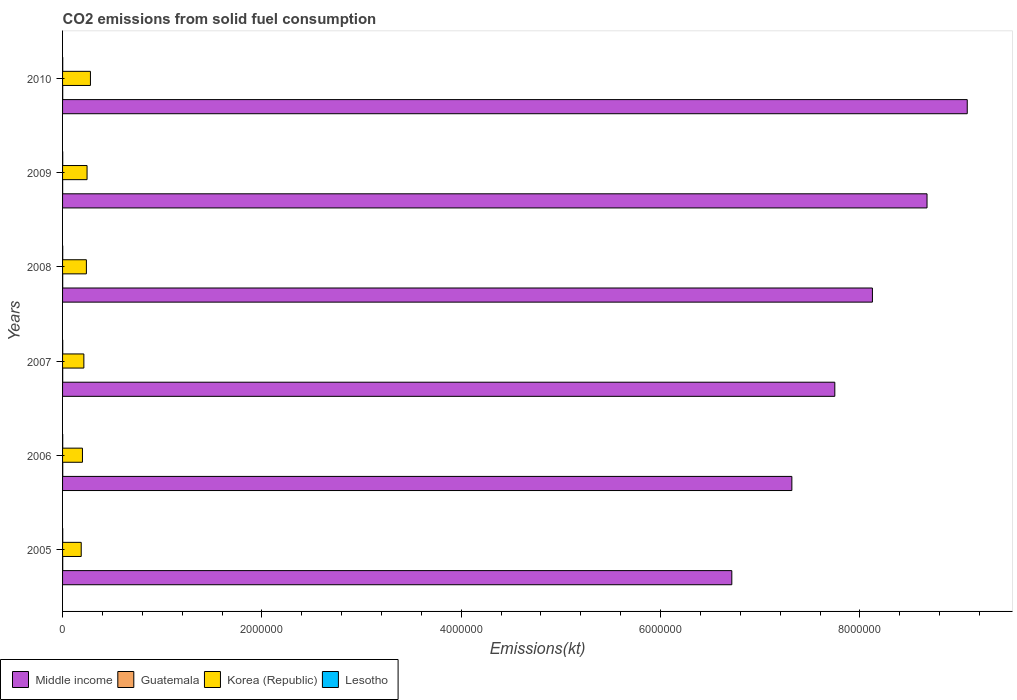How many different coloured bars are there?
Ensure brevity in your answer.  4. Are the number of bars per tick equal to the number of legend labels?
Your response must be concise. Yes. What is the label of the 1st group of bars from the top?
Your answer should be very brief. 2010. In how many cases, is the number of bars for a given year not equal to the number of legend labels?
Provide a short and direct response. 0. What is the amount of CO2 emitted in Middle income in 2008?
Your answer should be very brief. 8.13e+06. Across all years, what is the maximum amount of CO2 emitted in Lesotho?
Provide a short and direct response. 1543.81. Across all years, what is the minimum amount of CO2 emitted in Middle income?
Ensure brevity in your answer.  6.71e+06. In which year was the amount of CO2 emitted in Korea (Republic) maximum?
Give a very brief answer. 2010. In which year was the amount of CO2 emitted in Korea (Republic) minimum?
Your answer should be compact. 2005. What is the total amount of CO2 emitted in Guatemala in the graph?
Make the answer very short. 7726.37. What is the difference between the amount of CO2 emitted in Lesotho in 2005 and that in 2010?
Make the answer very short. -124.68. What is the difference between the amount of CO2 emitted in Korea (Republic) in 2010 and the amount of CO2 emitted in Guatemala in 2007?
Provide a short and direct response. 2.78e+05. What is the average amount of CO2 emitted in Guatemala per year?
Your answer should be compact. 1287.73. In the year 2006, what is the difference between the amount of CO2 emitted in Lesotho and amount of CO2 emitted in Korea (Republic)?
Make the answer very short. -1.98e+05. In how many years, is the amount of CO2 emitted in Middle income greater than 4800000 kt?
Provide a succinct answer. 6. What is the ratio of the amount of CO2 emitted in Middle income in 2006 to that in 2007?
Your response must be concise. 0.94. What is the difference between the highest and the second highest amount of CO2 emitted in Lesotho?
Your response must be concise. 25.67. What is the difference between the highest and the lowest amount of CO2 emitted in Guatemala?
Your answer should be compact. 909.42. Is it the case that in every year, the sum of the amount of CO2 emitted in Middle income and amount of CO2 emitted in Korea (Republic) is greater than the sum of amount of CO2 emitted in Lesotho and amount of CO2 emitted in Guatemala?
Your response must be concise. Yes. What does the 1st bar from the top in 2008 represents?
Your response must be concise. Lesotho. How many bars are there?
Make the answer very short. 24. Are the values on the major ticks of X-axis written in scientific E-notation?
Offer a terse response. No. Does the graph contain grids?
Provide a short and direct response. No. How are the legend labels stacked?
Ensure brevity in your answer.  Horizontal. What is the title of the graph?
Provide a succinct answer. CO2 emissions from solid fuel consumption. What is the label or title of the X-axis?
Your answer should be very brief. Emissions(kt). What is the label or title of the Y-axis?
Make the answer very short. Years. What is the Emissions(kt) in Middle income in 2005?
Provide a succinct answer. 6.71e+06. What is the Emissions(kt) in Guatemala in 2005?
Keep it short and to the point. 1562.14. What is the Emissions(kt) in Korea (Republic) in 2005?
Provide a short and direct response. 1.87e+05. What is the Emissions(kt) in Lesotho in 2005?
Keep it short and to the point. 1419.13. What is the Emissions(kt) in Middle income in 2006?
Provide a succinct answer. 7.32e+06. What is the Emissions(kt) of Guatemala in 2006?
Your answer should be compact. 1690.49. What is the Emissions(kt) in Korea (Republic) in 2006?
Keep it short and to the point. 2.00e+05. What is the Emissions(kt) of Lesotho in 2006?
Offer a very short reply. 1444.8. What is the Emissions(kt) in Middle income in 2007?
Make the answer very short. 7.75e+06. What is the Emissions(kt) of Guatemala in 2007?
Provide a succinct answer. 1188.11. What is the Emissions(kt) in Korea (Republic) in 2007?
Make the answer very short. 2.14e+05. What is the Emissions(kt) of Lesotho in 2007?
Provide a succinct answer. 1466.8. What is the Emissions(kt) of Middle income in 2008?
Your response must be concise. 8.13e+06. What is the Emissions(kt) of Guatemala in 2008?
Offer a very short reply. 1199.11. What is the Emissions(kt) of Korea (Republic) in 2008?
Provide a succinct answer. 2.39e+05. What is the Emissions(kt) in Lesotho in 2008?
Your answer should be very brief. 1496.14. What is the Emissions(kt) in Middle income in 2009?
Keep it short and to the point. 8.67e+06. What is the Emissions(kt) of Guatemala in 2009?
Give a very brief answer. 781.07. What is the Emissions(kt) of Korea (Republic) in 2009?
Provide a short and direct response. 2.46e+05. What is the Emissions(kt) in Lesotho in 2009?
Ensure brevity in your answer.  1518.14. What is the Emissions(kt) of Middle income in 2010?
Your response must be concise. 9.08e+06. What is the Emissions(kt) in Guatemala in 2010?
Keep it short and to the point. 1305.45. What is the Emissions(kt) in Korea (Republic) in 2010?
Your answer should be compact. 2.80e+05. What is the Emissions(kt) of Lesotho in 2010?
Offer a very short reply. 1543.81. Across all years, what is the maximum Emissions(kt) in Middle income?
Provide a succinct answer. 9.08e+06. Across all years, what is the maximum Emissions(kt) in Guatemala?
Offer a terse response. 1690.49. Across all years, what is the maximum Emissions(kt) in Korea (Republic)?
Your answer should be very brief. 2.80e+05. Across all years, what is the maximum Emissions(kt) of Lesotho?
Keep it short and to the point. 1543.81. Across all years, what is the minimum Emissions(kt) of Middle income?
Ensure brevity in your answer.  6.71e+06. Across all years, what is the minimum Emissions(kt) of Guatemala?
Offer a terse response. 781.07. Across all years, what is the minimum Emissions(kt) in Korea (Republic)?
Your answer should be compact. 1.87e+05. Across all years, what is the minimum Emissions(kt) in Lesotho?
Make the answer very short. 1419.13. What is the total Emissions(kt) in Middle income in the graph?
Offer a terse response. 4.77e+07. What is the total Emissions(kt) in Guatemala in the graph?
Ensure brevity in your answer.  7726.37. What is the total Emissions(kt) of Korea (Republic) in the graph?
Offer a terse response. 1.36e+06. What is the total Emissions(kt) of Lesotho in the graph?
Your answer should be compact. 8888.81. What is the difference between the Emissions(kt) of Middle income in 2005 and that in 2006?
Provide a succinct answer. -6.02e+05. What is the difference between the Emissions(kt) in Guatemala in 2005 and that in 2006?
Give a very brief answer. -128.34. What is the difference between the Emissions(kt) in Korea (Republic) in 2005 and that in 2006?
Keep it short and to the point. -1.24e+04. What is the difference between the Emissions(kt) of Lesotho in 2005 and that in 2006?
Offer a terse response. -25.67. What is the difference between the Emissions(kt) of Middle income in 2005 and that in 2007?
Give a very brief answer. -1.03e+06. What is the difference between the Emissions(kt) in Guatemala in 2005 and that in 2007?
Make the answer very short. 374.03. What is the difference between the Emissions(kt) in Korea (Republic) in 2005 and that in 2007?
Your response must be concise. -2.65e+04. What is the difference between the Emissions(kt) of Lesotho in 2005 and that in 2007?
Provide a short and direct response. -47.67. What is the difference between the Emissions(kt) in Middle income in 2005 and that in 2008?
Your answer should be compact. -1.41e+06. What is the difference between the Emissions(kt) in Guatemala in 2005 and that in 2008?
Ensure brevity in your answer.  363.03. What is the difference between the Emissions(kt) of Korea (Republic) in 2005 and that in 2008?
Your answer should be compact. -5.19e+04. What is the difference between the Emissions(kt) in Lesotho in 2005 and that in 2008?
Make the answer very short. -77.01. What is the difference between the Emissions(kt) in Middle income in 2005 and that in 2009?
Ensure brevity in your answer.  -1.96e+06. What is the difference between the Emissions(kt) of Guatemala in 2005 and that in 2009?
Offer a terse response. 781.07. What is the difference between the Emissions(kt) of Korea (Republic) in 2005 and that in 2009?
Your answer should be very brief. -5.86e+04. What is the difference between the Emissions(kt) in Lesotho in 2005 and that in 2009?
Offer a very short reply. -99.01. What is the difference between the Emissions(kt) in Middle income in 2005 and that in 2010?
Make the answer very short. -2.36e+06. What is the difference between the Emissions(kt) in Guatemala in 2005 and that in 2010?
Keep it short and to the point. 256.69. What is the difference between the Emissions(kt) in Korea (Republic) in 2005 and that in 2010?
Give a very brief answer. -9.25e+04. What is the difference between the Emissions(kt) in Lesotho in 2005 and that in 2010?
Give a very brief answer. -124.68. What is the difference between the Emissions(kt) in Middle income in 2006 and that in 2007?
Ensure brevity in your answer.  -4.31e+05. What is the difference between the Emissions(kt) of Guatemala in 2006 and that in 2007?
Your answer should be very brief. 502.38. What is the difference between the Emissions(kt) of Korea (Republic) in 2006 and that in 2007?
Make the answer very short. -1.40e+04. What is the difference between the Emissions(kt) in Lesotho in 2006 and that in 2007?
Ensure brevity in your answer.  -22. What is the difference between the Emissions(kt) of Middle income in 2006 and that in 2008?
Provide a short and direct response. -8.08e+05. What is the difference between the Emissions(kt) in Guatemala in 2006 and that in 2008?
Keep it short and to the point. 491.38. What is the difference between the Emissions(kt) of Korea (Republic) in 2006 and that in 2008?
Your answer should be very brief. -3.95e+04. What is the difference between the Emissions(kt) in Lesotho in 2006 and that in 2008?
Provide a succinct answer. -51.34. What is the difference between the Emissions(kt) of Middle income in 2006 and that in 2009?
Keep it short and to the point. -1.36e+06. What is the difference between the Emissions(kt) of Guatemala in 2006 and that in 2009?
Offer a very short reply. 909.42. What is the difference between the Emissions(kt) of Korea (Republic) in 2006 and that in 2009?
Ensure brevity in your answer.  -4.62e+04. What is the difference between the Emissions(kt) of Lesotho in 2006 and that in 2009?
Your answer should be compact. -73.34. What is the difference between the Emissions(kt) in Middle income in 2006 and that in 2010?
Offer a very short reply. -1.76e+06. What is the difference between the Emissions(kt) in Guatemala in 2006 and that in 2010?
Provide a short and direct response. 385.04. What is the difference between the Emissions(kt) in Korea (Republic) in 2006 and that in 2010?
Your response must be concise. -8.01e+04. What is the difference between the Emissions(kt) of Lesotho in 2006 and that in 2010?
Keep it short and to the point. -99.01. What is the difference between the Emissions(kt) of Middle income in 2007 and that in 2008?
Your answer should be very brief. -3.77e+05. What is the difference between the Emissions(kt) in Guatemala in 2007 and that in 2008?
Provide a short and direct response. -11. What is the difference between the Emissions(kt) of Korea (Republic) in 2007 and that in 2008?
Provide a short and direct response. -2.55e+04. What is the difference between the Emissions(kt) in Lesotho in 2007 and that in 2008?
Give a very brief answer. -29.34. What is the difference between the Emissions(kt) in Middle income in 2007 and that in 2009?
Your answer should be very brief. -9.25e+05. What is the difference between the Emissions(kt) in Guatemala in 2007 and that in 2009?
Give a very brief answer. 407.04. What is the difference between the Emissions(kt) in Korea (Republic) in 2007 and that in 2009?
Offer a very short reply. -3.22e+04. What is the difference between the Emissions(kt) of Lesotho in 2007 and that in 2009?
Keep it short and to the point. -51.34. What is the difference between the Emissions(kt) in Middle income in 2007 and that in 2010?
Your response must be concise. -1.33e+06. What is the difference between the Emissions(kt) of Guatemala in 2007 and that in 2010?
Your answer should be compact. -117.34. What is the difference between the Emissions(kt) in Korea (Republic) in 2007 and that in 2010?
Provide a succinct answer. -6.61e+04. What is the difference between the Emissions(kt) in Lesotho in 2007 and that in 2010?
Ensure brevity in your answer.  -77.01. What is the difference between the Emissions(kt) of Middle income in 2008 and that in 2009?
Keep it short and to the point. -5.48e+05. What is the difference between the Emissions(kt) of Guatemala in 2008 and that in 2009?
Your answer should be compact. 418.04. What is the difference between the Emissions(kt) in Korea (Republic) in 2008 and that in 2009?
Your answer should be very brief. -6703.28. What is the difference between the Emissions(kt) of Lesotho in 2008 and that in 2009?
Make the answer very short. -22. What is the difference between the Emissions(kt) in Middle income in 2008 and that in 2010?
Your answer should be compact. -9.51e+05. What is the difference between the Emissions(kt) in Guatemala in 2008 and that in 2010?
Provide a short and direct response. -106.34. What is the difference between the Emissions(kt) in Korea (Republic) in 2008 and that in 2010?
Your answer should be compact. -4.06e+04. What is the difference between the Emissions(kt) in Lesotho in 2008 and that in 2010?
Your answer should be very brief. -47.67. What is the difference between the Emissions(kt) in Middle income in 2009 and that in 2010?
Offer a very short reply. -4.04e+05. What is the difference between the Emissions(kt) of Guatemala in 2009 and that in 2010?
Offer a very short reply. -524.38. What is the difference between the Emissions(kt) in Korea (Republic) in 2009 and that in 2010?
Provide a succinct answer. -3.39e+04. What is the difference between the Emissions(kt) of Lesotho in 2009 and that in 2010?
Provide a short and direct response. -25.67. What is the difference between the Emissions(kt) of Middle income in 2005 and the Emissions(kt) of Guatemala in 2006?
Offer a very short reply. 6.71e+06. What is the difference between the Emissions(kt) in Middle income in 2005 and the Emissions(kt) in Korea (Republic) in 2006?
Offer a terse response. 6.52e+06. What is the difference between the Emissions(kt) in Middle income in 2005 and the Emissions(kt) in Lesotho in 2006?
Your answer should be very brief. 6.71e+06. What is the difference between the Emissions(kt) of Guatemala in 2005 and the Emissions(kt) of Korea (Republic) in 2006?
Keep it short and to the point. -1.98e+05. What is the difference between the Emissions(kt) in Guatemala in 2005 and the Emissions(kt) in Lesotho in 2006?
Your answer should be compact. 117.34. What is the difference between the Emissions(kt) of Korea (Republic) in 2005 and the Emissions(kt) of Lesotho in 2006?
Give a very brief answer. 1.86e+05. What is the difference between the Emissions(kt) of Middle income in 2005 and the Emissions(kt) of Guatemala in 2007?
Your answer should be very brief. 6.71e+06. What is the difference between the Emissions(kt) of Middle income in 2005 and the Emissions(kt) of Korea (Republic) in 2007?
Provide a succinct answer. 6.50e+06. What is the difference between the Emissions(kt) of Middle income in 2005 and the Emissions(kt) of Lesotho in 2007?
Keep it short and to the point. 6.71e+06. What is the difference between the Emissions(kt) in Guatemala in 2005 and the Emissions(kt) in Korea (Republic) in 2007?
Ensure brevity in your answer.  -2.12e+05. What is the difference between the Emissions(kt) of Guatemala in 2005 and the Emissions(kt) of Lesotho in 2007?
Your answer should be compact. 95.34. What is the difference between the Emissions(kt) in Korea (Republic) in 2005 and the Emissions(kt) in Lesotho in 2007?
Offer a very short reply. 1.86e+05. What is the difference between the Emissions(kt) of Middle income in 2005 and the Emissions(kt) of Guatemala in 2008?
Keep it short and to the point. 6.71e+06. What is the difference between the Emissions(kt) in Middle income in 2005 and the Emissions(kt) in Korea (Republic) in 2008?
Your response must be concise. 6.48e+06. What is the difference between the Emissions(kt) in Middle income in 2005 and the Emissions(kt) in Lesotho in 2008?
Make the answer very short. 6.71e+06. What is the difference between the Emissions(kt) in Guatemala in 2005 and the Emissions(kt) in Korea (Republic) in 2008?
Offer a terse response. -2.37e+05. What is the difference between the Emissions(kt) in Guatemala in 2005 and the Emissions(kt) in Lesotho in 2008?
Give a very brief answer. 66.01. What is the difference between the Emissions(kt) of Korea (Republic) in 2005 and the Emissions(kt) of Lesotho in 2008?
Your response must be concise. 1.86e+05. What is the difference between the Emissions(kt) of Middle income in 2005 and the Emissions(kt) of Guatemala in 2009?
Your answer should be very brief. 6.71e+06. What is the difference between the Emissions(kt) of Middle income in 2005 and the Emissions(kt) of Korea (Republic) in 2009?
Offer a terse response. 6.47e+06. What is the difference between the Emissions(kt) of Middle income in 2005 and the Emissions(kt) of Lesotho in 2009?
Give a very brief answer. 6.71e+06. What is the difference between the Emissions(kt) of Guatemala in 2005 and the Emissions(kt) of Korea (Republic) in 2009?
Offer a very short reply. -2.44e+05. What is the difference between the Emissions(kt) of Guatemala in 2005 and the Emissions(kt) of Lesotho in 2009?
Offer a very short reply. 44. What is the difference between the Emissions(kt) of Korea (Republic) in 2005 and the Emissions(kt) of Lesotho in 2009?
Offer a terse response. 1.86e+05. What is the difference between the Emissions(kt) in Middle income in 2005 and the Emissions(kt) in Guatemala in 2010?
Keep it short and to the point. 6.71e+06. What is the difference between the Emissions(kt) in Middle income in 2005 and the Emissions(kt) in Korea (Republic) in 2010?
Your response must be concise. 6.44e+06. What is the difference between the Emissions(kt) in Middle income in 2005 and the Emissions(kt) in Lesotho in 2010?
Provide a succinct answer. 6.71e+06. What is the difference between the Emissions(kt) in Guatemala in 2005 and the Emissions(kt) in Korea (Republic) in 2010?
Give a very brief answer. -2.78e+05. What is the difference between the Emissions(kt) of Guatemala in 2005 and the Emissions(kt) of Lesotho in 2010?
Keep it short and to the point. 18.34. What is the difference between the Emissions(kt) of Korea (Republic) in 2005 and the Emissions(kt) of Lesotho in 2010?
Your answer should be very brief. 1.86e+05. What is the difference between the Emissions(kt) of Middle income in 2006 and the Emissions(kt) of Guatemala in 2007?
Your answer should be very brief. 7.32e+06. What is the difference between the Emissions(kt) of Middle income in 2006 and the Emissions(kt) of Korea (Republic) in 2007?
Offer a very short reply. 7.10e+06. What is the difference between the Emissions(kt) in Middle income in 2006 and the Emissions(kt) in Lesotho in 2007?
Make the answer very short. 7.32e+06. What is the difference between the Emissions(kt) in Guatemala in 2006 and the Emissions(kt) in Korea (Republic) in 2007?
Give a very brief answer. -2.12e+05. What is the difference between the Emissions(kt) of Guatemala in 2006 and the Emissions(kt) of Lesotho in 2007?
Provide a short and direct response. 223.69. What is the difference between the Emissions(kt) in Korea (Republic) in 2006 and the Emissions(kt) in Lesotho in 2007?
Offer a very short reply. 1.98e+05. What is the difference between the Emissions(kt) of Middle income in 2006 and the Emissions(kt) of Guatemala in 2008?
Provide a succinct answer. 7.32e+06. What is the difference between the Emissions(kt) in Middle income in 2006 and the Emissions(kt) in Korea (Republic) in 2008?
Give a very brief answer. 7.08e+06. What is the difference between the Emissions(kt) in Middle income in 2006 and the Emissions(kt) in Lesotho in 2008?
Give a very brief answer. 7.32e+06. What is the difference between the Emissions(kt) in Guatemala in 2006 and the Emissions(kt) in Korea (Republic) in 2008?
Offer a very short reply. -2.37e+05. What is the difference between the Emissions(kt) of Guatemala in 2006 and the Emissions(kt) of Lesotho in 2008?
Keep it short and to the point. 194.35. What is the difference between the Emissions(kt) of Korea (Republic) in 2006 and the Emissions(kt) of Lesotho in 2008?
Give a very brief answer. 1.98e+05. What is the difference between the Emissions(kt) of Middle income in 2006 and the Emissions(kt) of Guatemala in 2009?
Keep it short and to the point. 7.32e+06. What is the difference between the Emissions(kt) in Middle income in 2006 and the Emissions(kt) in Korea (Republic) in 2009?
Offer a very short reply. 7.07e+06. What is the difference between the Emissions(kt) in Middle income in 2006 and the Emissions(kt) in Lesotho in 2009?
Provide a short and direct response. 7.32e+06. What is the difference between the Emissions(kt) of Guatemala in 2006 and the Emissions(kt) of Korea (Republic) in 2009?
Provide a succinct answer. -2.44e+05. What is the difference between the Emissions(kt) of Guatemala in 2006 and the Emissions(kt) of Lesotho in 2009?
Provide a succinct answer. 172.35. What is the difference between the Emissions(kt) of Korea (Republic) in 2006 and the Emissions(kt) of Lesotho in 2009?
Offer a terse response. 1.98e+05. What is the difference between the Emissions(kt) in Middle income in 2006 and the Emissions(kt) in Guatemala in 2010?
Offer a very short reply. 7.32e+06. What is the difference between the Emissions(kt) in Middle income in 2006 and the Emissions(kt) in Korea (Republic) in 2010?
Provide a succinct answer. 7.04e+06. What is the difference between the Emissions(kt) of Middle income in 2006 and the Emissions(kt) of Lesotho in 2010?
Offer a very short reply. 7.32e+06. What is the difference between the Emissions(kt) in Guatemala in 2006 and the Emissions(kt) in Korea (Republic) in 2010?
Your response must be concise. -2.78e+05. What is the difference between the Emissions(kt) of Guatemala in 2006 and the Emissions(kt) of Lesotho in 2010?
Give a very brief answer. 146.68. What is the difference between the Emissions(kt) in Korea (Republic) in 2006 and the Emissions(kt) in Lesotho in 2010?
Ensure brevity in your answer.  1.98e+05. What is the difference between the Emissions(kt) in Middle income in 2007 and the Emissions(kt) in Guatemala in 2008?
Provide a succinct answer. 7.75e+06. What is the difference between the Emissions(kt) in Middle income in 2007 and the Emissions(kt) in Korea (Republic) in 2008?
Your answer should be compact. 7.51e+06. What is the difference between the Emissions(kt) of Middle income in 2007 and the Emissions(kt) of Lesotho in 2008?
Offer a terse response. 7.75e+06. What is the difference between the Emissions(kt) of Guatemala in 2007 and the Emissions(kt) of Korea (Republic) in 2008?
Give a very brief answer. -2.38e+05. What is the difference between the Emissions(kt) of Guatemala in 2007 and the Emissions(kt) of Lesotho in 2008?
Offer a very short reply. -308.03. What is the difference between the Emissions(kt) of Korea (Republic) in 2007 and the Emissions(kt) of Lesotho in 2008?
Offer a terse response. 2.12e+05. What is the difference between the Emissions(kt) of Middle income in 2007 and the Emissions(kt) of Guatemala in 2009?
Your answer should be compact. 7.75e+06. What is the difference between the Emissions(kt) in Middle income in 2007 and the Emissions(kt) in Korea (Republic) in 2009?
Offer a very short reply. 7.50e+06. What is the difference between the Emissions(kt) in Middle income in 2007 and the Emissions(kt) in Lesotho in 2009?
Your answer should be compact. 7.75e+06. What is the difference between the Emissions(kt) of Guatemala in 2007 and the Emissions(kt) of Korea (Republic) in 2009?
Keep it short and to the point. -2.45e+05. What is the difference between the Emissions(kt) of Guatemala in 2007 and the Emissions(kt) of Lesotho in 2009?
Keep it short and to the point. -330.03. What is the difference between the Emissions(kt) in Korea (Republic) in 2007 and the Emissions(kt) in Lesotho in 2009?
Offer a terse response. 2.12e+05. What is the difference between the Emissions(kt) of Middle income in 2007 and the Emissions(kt) of Guatemala in 2010?
Give a very brief answer. 7.75e+06. What is the difference between the Emissions(kt) in Middle income in 2007 and the Emissions(kt) in Korea (Republic) in 2010?
Keep it short and to the point. 7.47e+06. What is the difference between the Emissions(kt) in Middle income in 2007 and the Emissions(kt) in Lesotho in 2010?
Keep it short and to the point. 7.75e+06. What is the difference between the Emissions(kt) in Guatemala in 2007 and the Emissions(kt) in Korea (Republic) in 2010?
Make the answer very short. -2.78e+05. What is the difference between the Emissions(kt) in Guatemala in 2007 and the Emissions(kt) in Lesotho in 2010?
Provide a short and direct response. -355.7. What is the difference between the Emissions(kt) in Korea (Republic) in 2007 and the Emissions(kt) in Lesotho in 2010?
Keep it short and to the point. 2.12e+05. What is the difference between the Emissions(kt) of Middle income in 2008 and the Emissions(kt) of Guatemala in 2009?
Ensure brevity in your answer.  8.12e+06. What is the difference between the Emissions(kt) in Middle income in 2008 and the Emissions(kt) in Korea (Republic) in 2009?
Ensure brevity in your answer.  7.88e+06. What is the difference between the Emissions(kt) in Middle income in 2008 and the Emissions(kt) in Lesotho in 2009?
Offer a terse response. 8.12e+06. What is the difference between the Emissions(kt) of Guatemala in 2008 and the Emissions(kt) of Korea (Republic) in 2009?
Your answer should be very brief. -2.45e+05. What is the difference between the Emissions(kt) in Guatemala in 2008 and the Emissions(kt) in Lesotho in 2009?
Ensure brevity in your answer.  -319.03. What is the difference between the Emissions(kt) in Korea (Republic) in 2008 and the Emissions(kt) in Lesotho in 2009?
Offer a very short reply. 2.38e+05. What is the difference between the Emissions(kt) in Middle income in 2008 and the Emissions(kt) in Guatemala in 2010?
Provide a succinct answer. 8.12e+06. What is the difference between the Emissions(kt) in Middle income in 2008 and the Emissions(kt) in Korea (Republic) in 2010?
Provide a succinct answer. 7.85e+06. What is the difference between the Emissions(kt) of Middle income in 2008 and the Emissions(kt) of Lesotho in 2010?
Make the answer very short. 8.12e+06. What is the difference between the Emissions(kt) in Guatemala in 2008 and the Emissions(kt) in Korea (Republic) in 2010?
Provide a succinct answer. -2.78e+05. What is the difference between the Emissions(kt) in Guatemala in 2008 and the Emissions(kt) in Lesotho in 2010?
Provide a short and direct response. -344.7. What is the difference between the Emissions(kt) in Korea (Republic) in 2008 and the Emissions(kt) in Lesotho in 2010?
Offer a terse response. 2.37e+05. What is the difference between the Emissions(kt) of Middle income in 2009 and the Emissions(kt) of Guatemala in 2010?
Offer a very short reply. 8.67e+06. What is the difference between the Emissions(kt) of Middle income in 2009 and the Emissions(kt) of Korea (Republic) in 2010?
Offer a terse response. 8.39e+06. What is the difference between the Emissions(kt) of Middle income in 2009 and the Emissions(kt) of Lesotho in 2010?
Provide a short and direct response. 8.67e+06. What is the difference between the Emissions(kt) in Guatemala in 2009 and the Emissions(kt) in Korea (Republic) in 2010?
Provide a succinct answer. -2.79e+05. What is the difference between the Emissions(kt) in Guatemala in 2009 and the Emissions(kt) in Lesotho in 2010?
Provide a short and direct response. -762.74. What is the difference between the Emissions(kt) of Korea (Republic) in 2009 and the Emissions(kt) of Lesotho in 2010?
Provide a succinct answer. 2.44e+05. What is the average Emissions(kt) in Middle income per year?
Give a very brief answer. 7.94e+06. What is the average Emissions(kt) of Guatemala per year?
Make the answer very short. 1287.73. What is the average Emissions(kt) of Korea (Republic) per year?
Your answer should be compact. 2.27e+05. What is the average Emissions(kt) in Lesotho per year?
Your answer should be very brief. 1481.47. In the year 2005, what is the difference between the Emissions(kt) in Middle income and Emissions(kt) in Guatemala?
Your answer should be very brief. 6.71e+06. In the year 2005, what is the difference between the Emissions(kt) of Middle income and Emissions(kt) of Korea (Republic)?
Your answer should be compact. 6.53e+06. In the year 2005, what is the difference between the Emissions(kt) of Middle income and Emissions(kt) of Lesotho?
Offer a terse response. 6.71e+06. In the year 2005, what is the difference between the Emissions(kt) of Guatemala and Emissions(kt) of Korea (Republic)?
Your answer should be compact. -1.86e+05. In the year 2005, what is the difference between the Emissions(kt) of Guatemala and Emissions(kt) of Lesotho?
Ensure brevity in your answer.  143.01. In the year 2005, what is the difference between the Emissions(kt) in Korea (Republic) and Emissions(kt) in Lesotho?
Offer a very short reply. 1.86e+05. In the year 2006, what is the difference between the Emissions(kt) of Middle income and Emissions(kt) of Guatemala?
Ensure brevity in your answer.  7.32e+06. In the year 2006, what is the difference between the Emissions(kt) in Middle income and Emissions(kt) in Korea (Republic)?
Make the answer very short. 7.12e+06. In the year 2006, what is the difference between the Emissions(kt) of Middle income and Emissions(kt) of Lesotho?
Give a very brief answer. 7.32e+06. In the year 2006, what is the difference between the Emissions(kt) of Guatemala and Emissions(kt) of Korea (Republic)?
Your answer should be very brief. -1.98e+05. In the year 2006, what is the difference between the Emissions(kt) in Guatemala and Emissions(kt) in Lesotho?
Ensure brevity in your answer.  245.69. In the year 2006, what is the difference between the Emissions(kt) of Korea (Republic) and Emissions(kt) of Lesotho?
Provide a short and direct response. 1.98e+05. In the year 2007, what is the difference between the Emissions(kt) in Middle income and Emissions(kt) in Guatemala?
Provide a succinct answer. 7.75e+06. In the year 2007, what is the difference between the Emissions(kt) in Middle income and Emissions(kt) in Korea (Republic)?
Keep it short and to the point. 7.53e+06. In the year 2007, what is the difference between the Emissions(kt) in Middle income and Emissions(kt) in Lesotho?
Keep it short and to the point. 7.75e+06. In the year 2007, what is the difference between the Emissions(kt) in Guatemala and Emissions(kt) in Korea (Republic)?
Your answer should be very brief. -2.12e+05. In the year 2007, what is the difference between the Emissions(kt) of Guatemala and Emissions(kt) of Lesotho?
Make the answer very short. -278.69. In the year 2007, what is the difference between the Emissions(kt) of Korea (Republic) and Emissions(kt) of Lesotho?
Keep it short and to the point. 2.12e+05. In the year 2008, what is the difference between the Emissions(kt) in Middle income and Emissions(kt) in Guatemala?
Keep it short and to the point. 8.12e+06. In the year 2008, what is the difference between the Emissions(kt) in Middle income and Emissions(kt) in Korea (Republic)?
Ensure brevity in your answer.  7.89e+06. In the year 2008, what is the difference between the Emissions(kt) of Middle income and Emissions(kt) of Lesotho?
Provide a short and direct response. 8.12e+06. In the year 2008, what is the difference between the Emissions(kt) in Guatemala and Emissions(kt) in Korea (Republic)?
Your answer should be very brief. -2.38e+05. In the year 2008, what is the difference between the Emissions(kt) in Guatemala and Emissions(kt) in Lesotho?
Keep it short and to the point. -297.03. In the year 2008, what is the difference between the Emissions(kt) of Korea (Republic) and Emissions(kt) of Lesotho?
Your answer should be very brief. 2.38e+05. In the year 2009, what is the difference between the Emissions(kt) in Middle income and Emissions(kt) in Guatemala?
Keep it short and to the point. 8.67e+06. In the year 2009, what is the difference between the Emissions(kt) of Middle income and Emissions(kt) of Korea (Republic)?
Ensure brevity in your answer.  8.43e+06. In the year 2009, what is the difference between the Emissions(kt) of Middle income and Emissions(kt) of Lesotho?
Your answer should be compact. 8.67e+06. In the year 2009, what is the difference between the Emissions(kt) of Guatemala and Emissions(kt) of Korea (Republic)?
Your answer should be very brief. -2.45e+05. In the year 2009, what is the difference between the Emissions(kt) in Guatemala and Emissions(kt) in Lesotho?
Offer a terse response. -737.07. In the year 2009, what is the difference between the Emissions(kt) in Korea (Republic) and Emissions(kt) in Lesotho?
Your response must be concise. 2.44e+05. In the year 2010, what is the difference between the Emissions(kt) of Middle income and Emissions(kt) of Guatemala?
Provide a succinct answer. 9.08e+06. In the year 2010, what is the difference between the Emissions(kt) of Middle income and Emissions(kt) of Korea (Republic)?
Keep it short and to the point. 8.80e+06. In the year 2010, what is the difference between the Emissions(kt) in Middle income and Emissions(kt) in Lesotho?
Provide a succinct answer. 9.08e+06. In the year 2010, what is the difference between the Emissions(kt) of Guatemala and Emissions(kt) of Korea (Republic)?
Offer a terse response. -2.78e+05. In the year 2010, what is the difference between the Emissions(kt) in Guatemala and Emissions(kt) in Lesotho?
Your answer should be compact. -238.35. In the year 2010, what is the difference between the Emissions(kt) of Korea (Republic) and Emissions(kt) of Lesotho?
Your answer should be compact. 2.78e+05. What is the ratio of the Emissions(kt) of Middle income in 2005 to that in 2006?
Your answer should be very brief. 0.92. What is the ratio of the Emissions(kt) of Guatemala in 2005 to that in 2006?
Your answer should be very brief. 0.92. What is the ratio of the Emissions(kt) in Korea (Republic) in 2005 to that in 2006?
Make the answer very short. 0.94. What is the ratio of the Emissions(kt) of Lesotho in 2005 to that in 2006?
Provide a succinct answer. 0.98. What is the ratio of the Emissions(kt) of Middle income in 2005 to that in 2007?
Provide a short and direct response. 0.87. What is the ratio of the Emissions(kt) of Guatemala in 2005 to that in 2007?
Make the answer very short. 1.31. What is the ratio of the Emissions(kt) in Korea (Republic) in 2005 to that in 2007?
Provide a short and direct response. 0.88. What is the ratio of the Emissions(kt) of Lesotho in 2005 to that in 2007?
Offer a terse response. 0.97. What is the ratio of the Emissions(kt) in Middle income in 2005 to that in 2008?
Keep it short and to the point. 0.83. What is the ratio of the Emissions(kt) of Guatemala in 2005 to that in 2008?
Your answer should be compact. 1.3. What is the ratio of the Emissions(kt) in Korea (Republic) in 2005 to that in 2008?
Your answer should be compact. 0.78. What is the ratio of the Emissions(kt) in Lesotho in 2005 to that in 2008?
Your response must be concise. 0.95. What is the ratio of the Emissions(kt) of Middle income in 2005 to that in 2009?
Ensure brevity in your answer.  0.77. What is the ratio of the Emissions(kt) of Guatemala in 2005 to that in 2009?
Your answer should be compact. 2. What is the ratio of the Emissions(kt) in Korea (Republic) in 2005 to that in 2009?
Provide a short and direct response. 0.76. What is the ratio of the Emissions(kt) in Lesotho in 2005 to that in 2009?
Make the answer very short. 0.93. What is the ratio of the Emissions(kt) in Middle income in 2005 to that in 2010?
Your answer should be very brief. 0.74. What is the ratio of the Emissions(kt) in Guatemala in 2005 to that in 2010?
Make the answer very short. 1.2. What is the ratio of the Emissions(kt) in Korea (Republic) in 2005 to that in 2010?
Offer a very short reply. 0.67. What is the ratio of the Emissions(kt) in Lesotho in 2005 to that in 2010?
Offer a terse response. 0.92. What is the ratio of the Emissions(kt) in Middle income in 2006 to that in 2007?
Your answer should be compact. 0.94. What is the ratio of the Emissions(kt) in Guatemala in 2006 to that in 2007?
Your answer should be compact. 1.42. What is the ratio of the Emissions(kt) in Korea (Republic) in 2006 to that in 2007?
Provide a short and direct response. 0.93. What is the ratio of the Emissions(kt) of Middle income in 2006 to that in 2008?
Offer a terse response. 0.9. What is the ratio of the Emissions(kt) of Guatemala in 2006 to that in 2008?
Keep it short and to the point. 1.41. What is the ratio of the Emissions(kt) of Korea (Republic) in 2006 to that in 2008?
Provide a succinct answer. 0.83. What is the ratio of the Emissions(kt) of Lesotho in 2006 to that in 2008?
Your answer should be compact. 0.97. What is the ratio of the Emissions(kt) of Middle income in 2006 to that in 2009?
Keep it short and to the point. 0.84. What is the ratio of the Emissions(kt) in Guatemala in 2006 to that in 2009?
Provide a short and direct response. 2.16. What is the ratio of the Emissions(kt) of Korea (Republic) in 2006 to that in 2009?
Keep it short and to the point. 0.81. What is the ratio of the Emissions(kt) in Lesotho in 2006 to that in 2009?
Ensure brevity in your answer.  0.95. What is the ratio of the Emissions(kt) of Middle income in 2006 to that in 2010?
Your response must be concise. 0.81. What is the ratio of the Emissions(kt) in Guatemala in 2006 to that in 2010?
Provide a short and direct response. 1.29. What is the ratio of the Emissions(kt) in Korea (Republic) in 2006 to that in 2010?
Provide a succinct answer. 0.71. What is the ratio of the Emissions(kt) of Lesotho in 2006 to that in 2010?
Provide a succinct answer. 0.94. What is the ratio of the Emissions(kt) of Middle income in 2007 to that in 2008?
Offer a terse response. 0.95. What is the ratio of the Emissions(kt) in Korea (Republic) in 2007 to that in 2008?
Keep it short and to the point. 0.89. What is the ratio of the Emissions(kt) in Lesotho in 2007 to that in 2008?
Your response must be concise. 0.98. What is the ratio of the Emissions(kt) in Middle income in 2007 to that in 2009?
Offer a terse response. 0.89. What is the ratio of the Emissions(kt) in Guatemala in 2007 to that in 2009?
Provide a succinct answer. 1.52. What is the ratio of the Emissions(kt) of Korea (Republic) in 2007 to that in 2009?
Your response must be concise. 0.87. What is the ratio of the Emissions(kt) in Lesotho in 2007 to that in 2009?
Provide a short and direct response. 0.97. What is the ratio of the Emissions(kt) of Middle income in 2007 to that in 2010?
Your answer should be compact. 0.85. What is the ratio of the Emissions(kt) in Guatemala in 2007 to that in 2010?
Your answer should be compact. 0.91. What is the ratio of the Emissions(kt) of Korea (Republic) in 2007 to that in 2010?
Provide a succinct answer. 0.76. What is the ratio of the Emissions(kt) of Lesotho in 2007 to that in 2010?
Your response must be concise. 0.95. What is the ratio of the Emissions(kt) in Middle income in 2008 to that in 2009?
Your answer should be compact. 0.94. What is the ratio of the Emissions(kt) in Guatemala in 2008 to that in 2009?
Ensure brevity in your answer.  1.54. What is the ratio of the Emissions(kt) in Korea (Republic) in 2008 to that in 2009?
Your response must be concise. 0.97. What is the ratio of the Emissions(kt) in Lesotho in 2008 to that in 2009?
Give a very brief answer. 0.99. What is the ratio of the Emissions(kt) of Middle income in 2008 to that in 2010?
Give a very brief answer. 0.9. What is the ratio of the Emissions(kt) in Guatemala in 2008 to that in 2010?
Your answer should be very brief. 0.92. What is the ratio of the Emissions(kt) of Korea (Republic) in 2008 to that in 2010?
Provide a succinct answer. 0.85. What is the ratio of the Emissions(kt) of Lesotho in 2008 to that in 2010?
Provide a succinct answer. 0.97. What is the ratio of the Emissions(kt) in Middle income in 2009 to that in 2010?
Offer a terse response. 0.96. What is the ratio of the Emissions(kt) in Guatemala in 2009 to that in 2010?
Your response must be concise. 0.6. What is the ratio of the Emissions(kt) in Korea (Republic) in 2009 to that in 2010?
Provide a short and direct response. 0.88. What is the ratio of the Emissions(kt) in Lesotho in 2009 to that in 2010?
Your response must be concise. 0.98. What is the difference between the highest and the second highest Emissions(kt) in Middle income?
Make the answer very short. 4.04e+05. What is the difference between the highest and the second highest Emissions(kt) in Guatemala?
Provide a succinct answer. 128.34. What is the difference between the highest and the second highest Emissions(kt) in Korea (Republic)?
Offer a very short reply. 3.39e+04. What is the difference between the highest and the second highest Emissions(kt) of Lesotho?
Offer a very short reply. 25.67. What is the difference between the highest and the lowest Emissions(kt) in Middle income?
Give a very brief answer. 2.36e+06. What is the difference between the highest and the lowest Emissions(kt) of Guatemala?
Your answer should be compact. 909.42. What is the difference between the highest and the lowest Emissions(kt) in Korea (Republic)?
Your response must be concise. 9.25e+04. What is the difference between the highest and the lowest Emissions(kt) in Lesotho?
Your response must be concise. 124.68. 